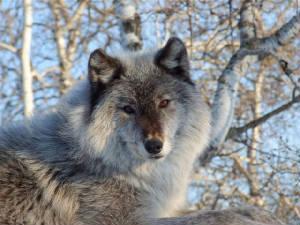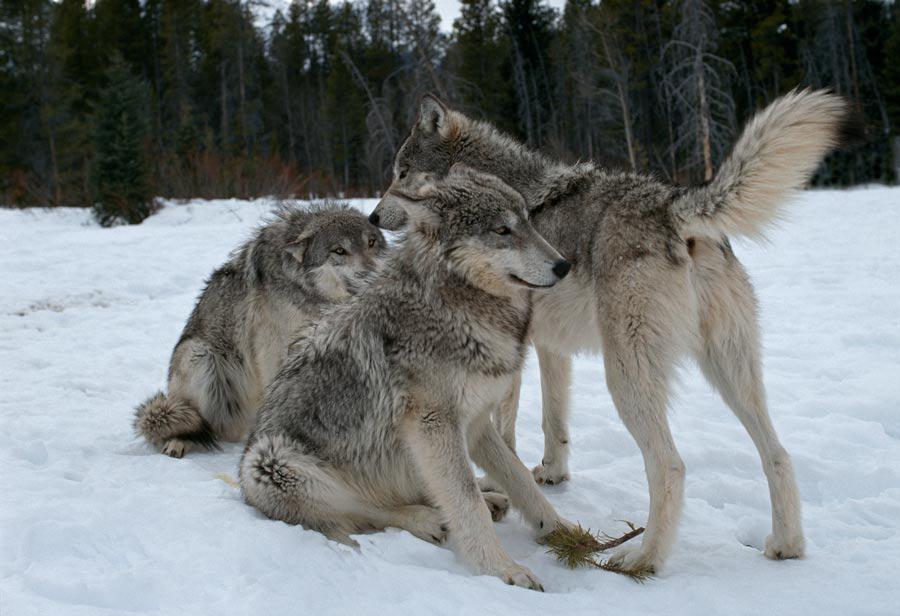The first image is the image on the left, the second image is the image on the right. Given the left and right images, does the statement "There are two wolves" hold true? Answer yes or no. No. 